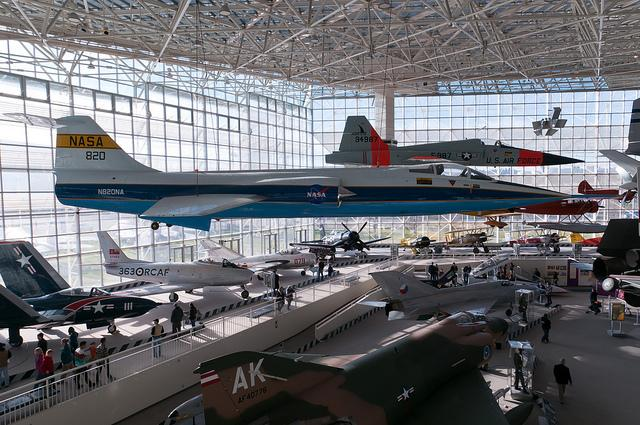What type of transportation is shown? Please explain your reasoning. air. The planes fly in the air. 